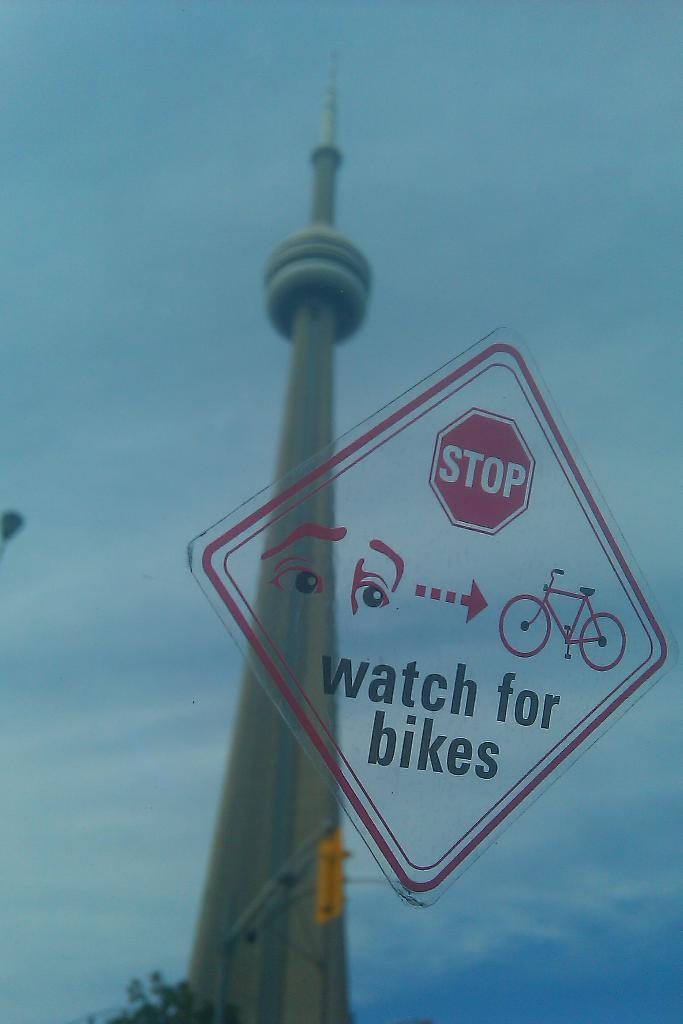<image>
Give a short and clear explanation of the subsequent image. A stop sign warning people to watch for bikes printed on a piece of glass. A monument can be seen in the reflection. 